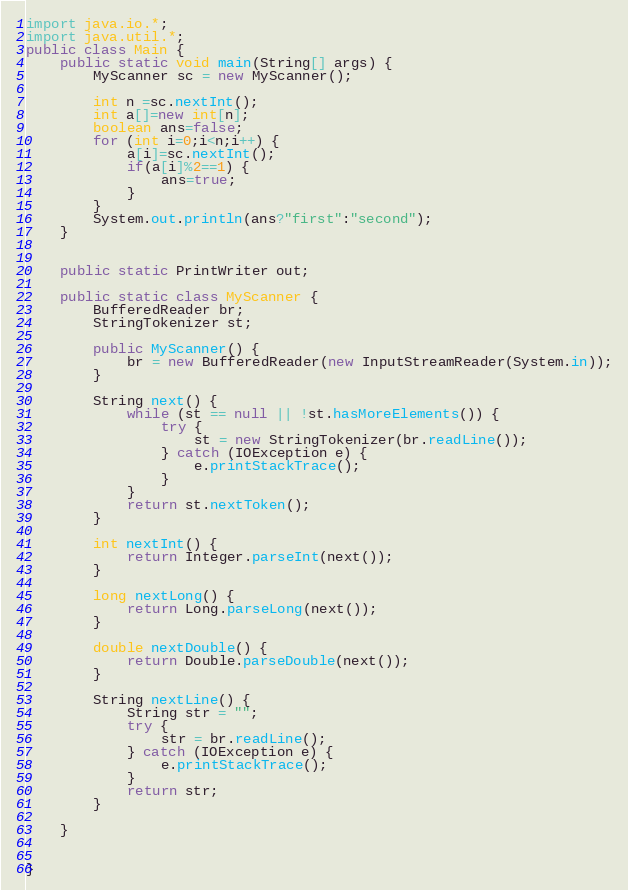<code> <loc_0><loc_0><loc_500><loc_500><_Java_>import java.io.*;
import java.util.*;
public class Main {
	public static void main(String[] args) {
		MyScanner sc = new MyScanner();
		
		int n =sc.nextInt();
		int a[]=new int[n];
		boolean ans=false;
		for (int i=0;i<n;i++) {
			a[i]=sc.nextInt();
			if(a[i]%2==1) {
				ans=true;
			}
		}
		System.out.println(ans?"first":"second");
	}
		
	
	public static PrintWriter out;

	public static class MyScanner {
		BufferedReader br;
		StringTokenizer st;

		public MyScanner() {
			br = new BufferedReader(new InputStreamReader(System.in));
		}

		String next() {
			while (st == null || !st.hasMoreElements()) {
				try {
					st = new StringTokenizer(br.readLine());
				} catch (IOException e) {
					e.printStackTrace();
				}
			}
			return st.nextToken();
		}

		int nextInt() {
			return Integer.parseInt(next());
		}

		long nextLong() {
			return Long.parseLong(next());
		}

		double nextDouble() {
			return Double.parseDouble(next());
		}

		String nextLine() {
			String str = "";
			try {
				str = br.readLine();
			} catch (IOException e) {
				e.printStackTrace();
			}
			return str;
		}

	}
	

}



</code> 